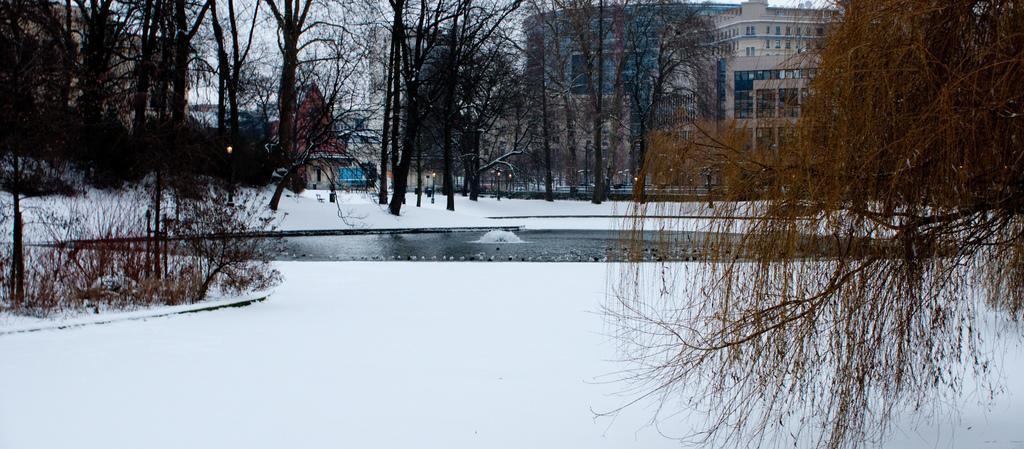What type of weather condition is depicted in the image? There is snow in the image, indicating a cold or wintry weather condition. What else can be seen in the image besides snow? There is water, plants, lights, poles, trees, buildings, and the sky visible in the image. Can you describe the lighting in the image? There are lights in the image, which may provide illumination or decoration. What type of structures are present in the image? There are buildings in the image, which may be residential, commercial, or public. Can you tell me how many rabbits are hopping around in the image? There are no rabbits present in the image. What level of expertise does the beginner have in the image? There is no indication of any beginner or level of expertise in the image. 